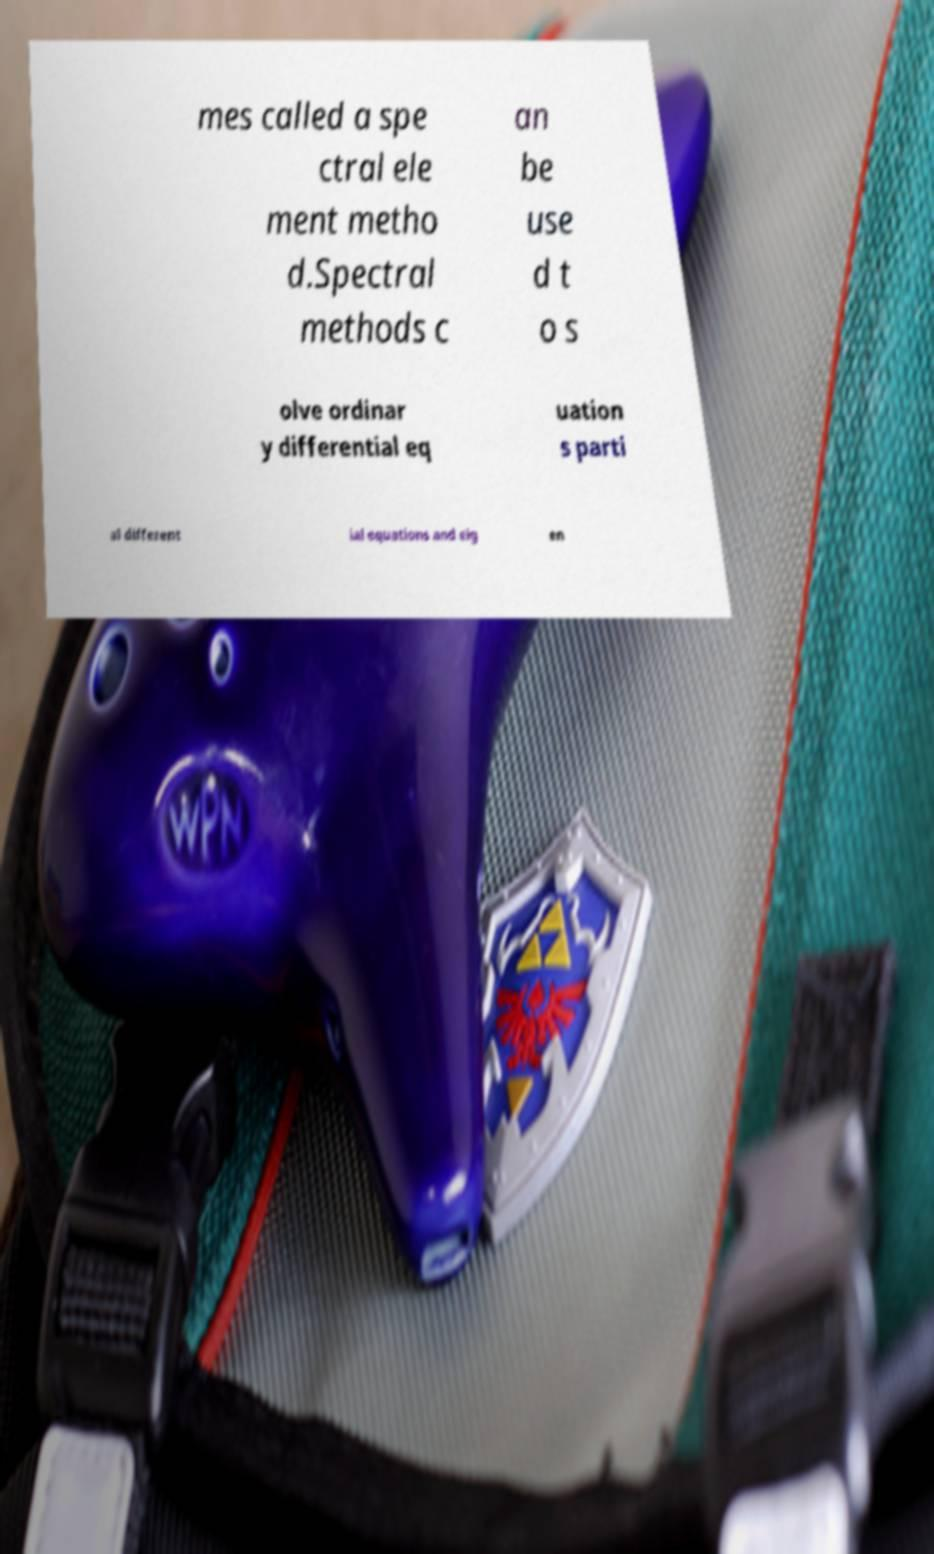I need the written content from this picture converted into text. Can you do that? mes called a spe ctral ele ment metho d.Spectral methods c an be use d t o s olve ordinar y differential eq uation s parti al different ial equations and eig en 